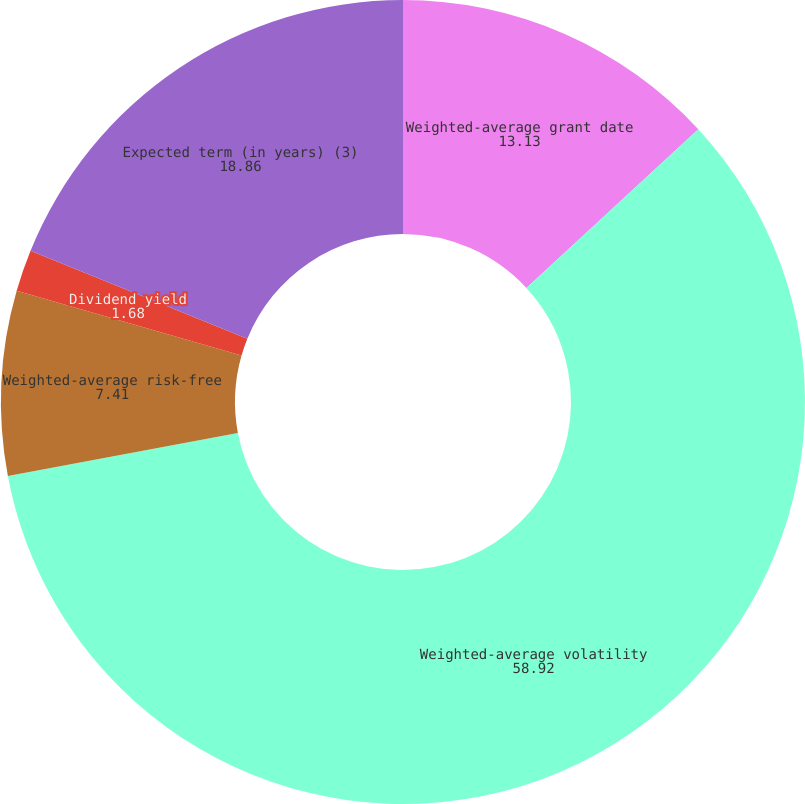<chart> <loc_0><loc_0><loc_500><loc_500><pie_chart><fcel>Weighted-average grant date<fcel>Weighted-average volatility<fcel>Weighted-average risk-free<fcel>Dividend yield<fcel>Expected term (in years) (3)<nl><fcel>13.13%<fcel>58.92%<fcel>7.41%<fcel>1.68%<fcel>18.86%<nl></chart> 